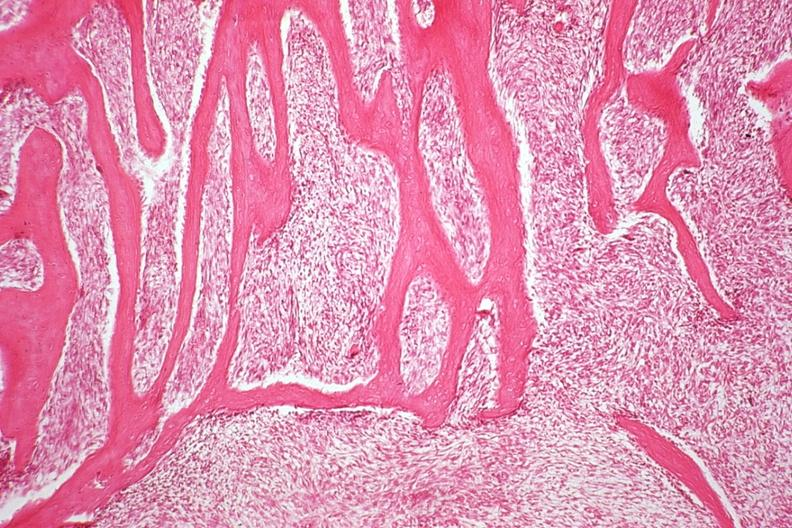what is present?
Answer the question using a single word or phrase. Joints 